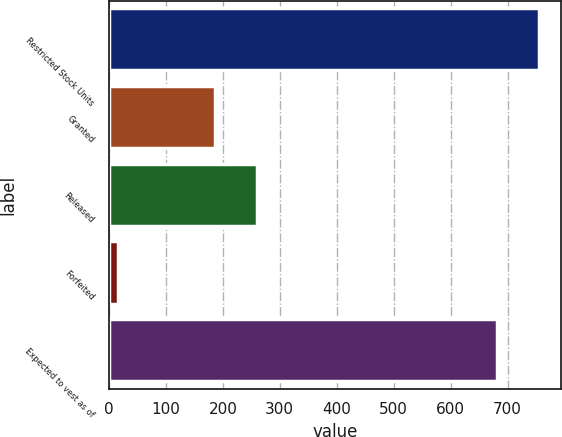Convert chart. <chart><loc_0><loc_0><loc_500><loc_500><bar_chart><fcel>Restricted Stock Units<fcel>Granted<fcel>Released<fcel>Forfeited<fcel>Expected to vest as of<nl><fcel>755.4<fcel>187<fcel>260.4<fcel>16<fcel>682<nl></chart> 